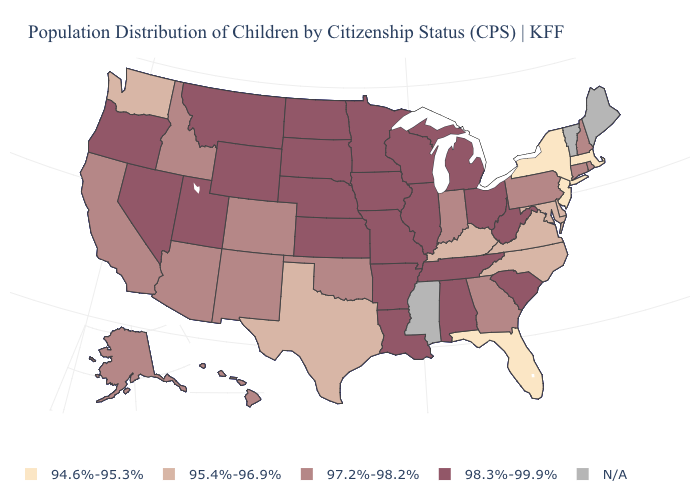Which states have the highest value in the USA?
Keep it brief. Alabama, Arkansas, Illinois, Iowa, Kansas, Louisiana, Michigan, Minnesota, Missouri, Montana, Nebraska, Nevada, North Dakota, Ohio, Oregon, South Carolina, South Dakota, Tennessee, Utah, West Virginia, Wisconsin, Wyoming. Among the states that border West Virginia , which have the lowest value?
Give a very brief answer. Kentucky, Maryland, Virginia. Name the states that have a value in the range 94.6%-95.3%?
Be succinct. Florida, Massachusetts, New Jersey, New York. Which states have the lowest value in the West?
Keep it brief. Washington. Name the states that have a value in the range N/A?
Concise answer only. Maine, Mississippi, Vermont. Which states have the lowest value in the South?
Short answer required. Florida. Name the states that have a value in the range 98.3%-99.9%?
Keep it brief. Alabama, Arkansas, Illinois, Iowa, Kansas, Louisiana, Michigan, Minnesota, Missouri, Montana, Nebraska, Nevada, North Dakota, Ohio, Oregon, South Carolina, South Dakota, Tennessee, Utah, West Virginia, Wisconsin, Wyoming. What is the lowest value in the South?
Short answer required. 94.6%-95.3%. What is the value of Rhode Island?
Be succinct. 97.2%-98.2%. Name the states that have a value in the range 98.3%-99.9%?
Be succinct. Alabama, Arkansas, Illinois, Iowa, Kansas, Louisiana, Michigan, Minnesota, Missouri, Montana, Nebraska, Nevada, North Dakota, Ohio, Oregon, South Carolina, South Dakota, Tennessee, Utah, West Virginia, Wisconsin, Wyoming. What is the lowest value in states that border Florida?
Concise answer only. 97.2%-98.2%. What is the value of Pennsylvania?
Answer briefly. 97.2%-98.2%. Does Utah have the highest value in the West?
Answer briefly. Yes. What is the highest value in states that border Oklahoma?
Concise answer only. 98.3%-99.9%. What is the value of Idaho?
Quick response, please. 97.2%-98.2%. 